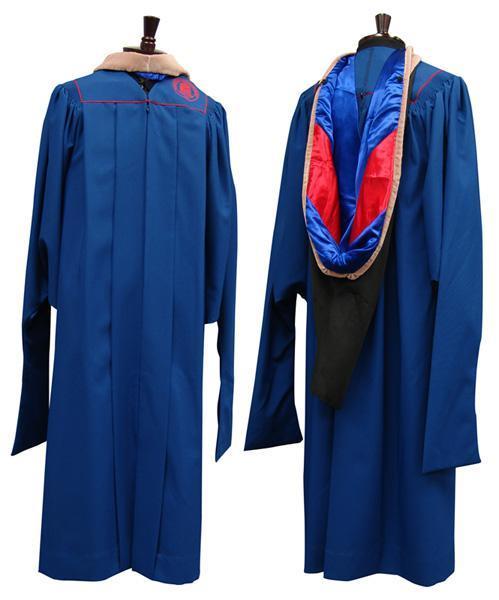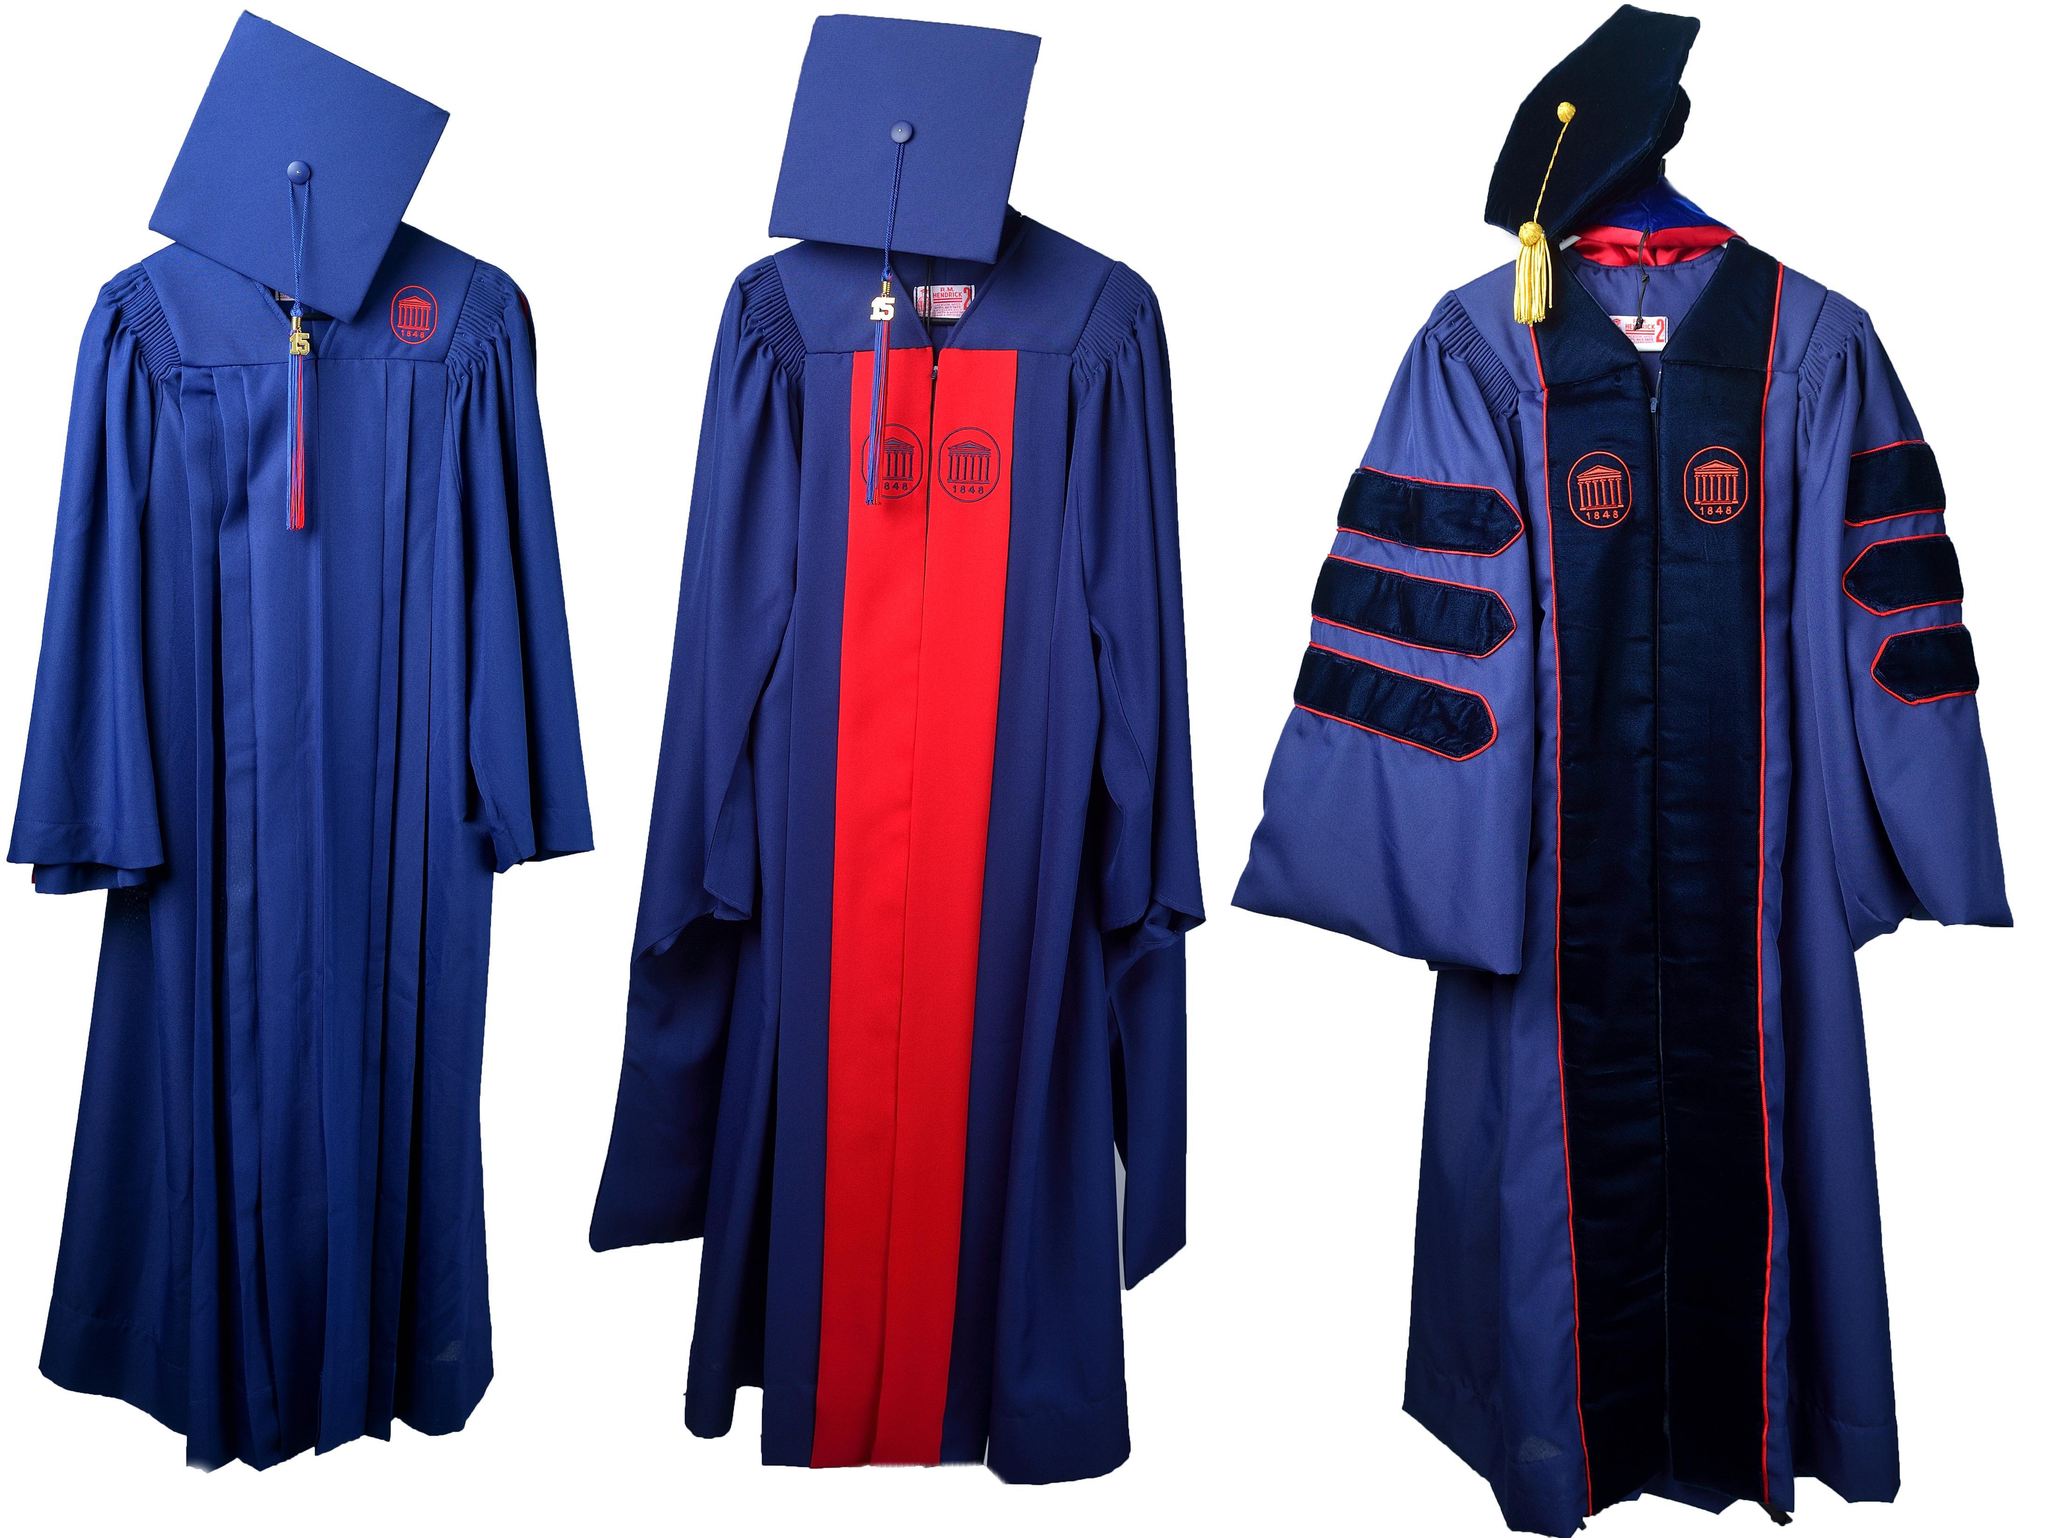The first image is the image on the left, the second image is the image on the right. Examine the images to the left and right. Is the description "All of the graduation caps are blue." accurate? Answer yes or no. No. The first image is the image on the left, the second image is the image on the right. Considering the images on both sides, is "Both images contain red and blue." valid? Answer yes or no. Yes. 